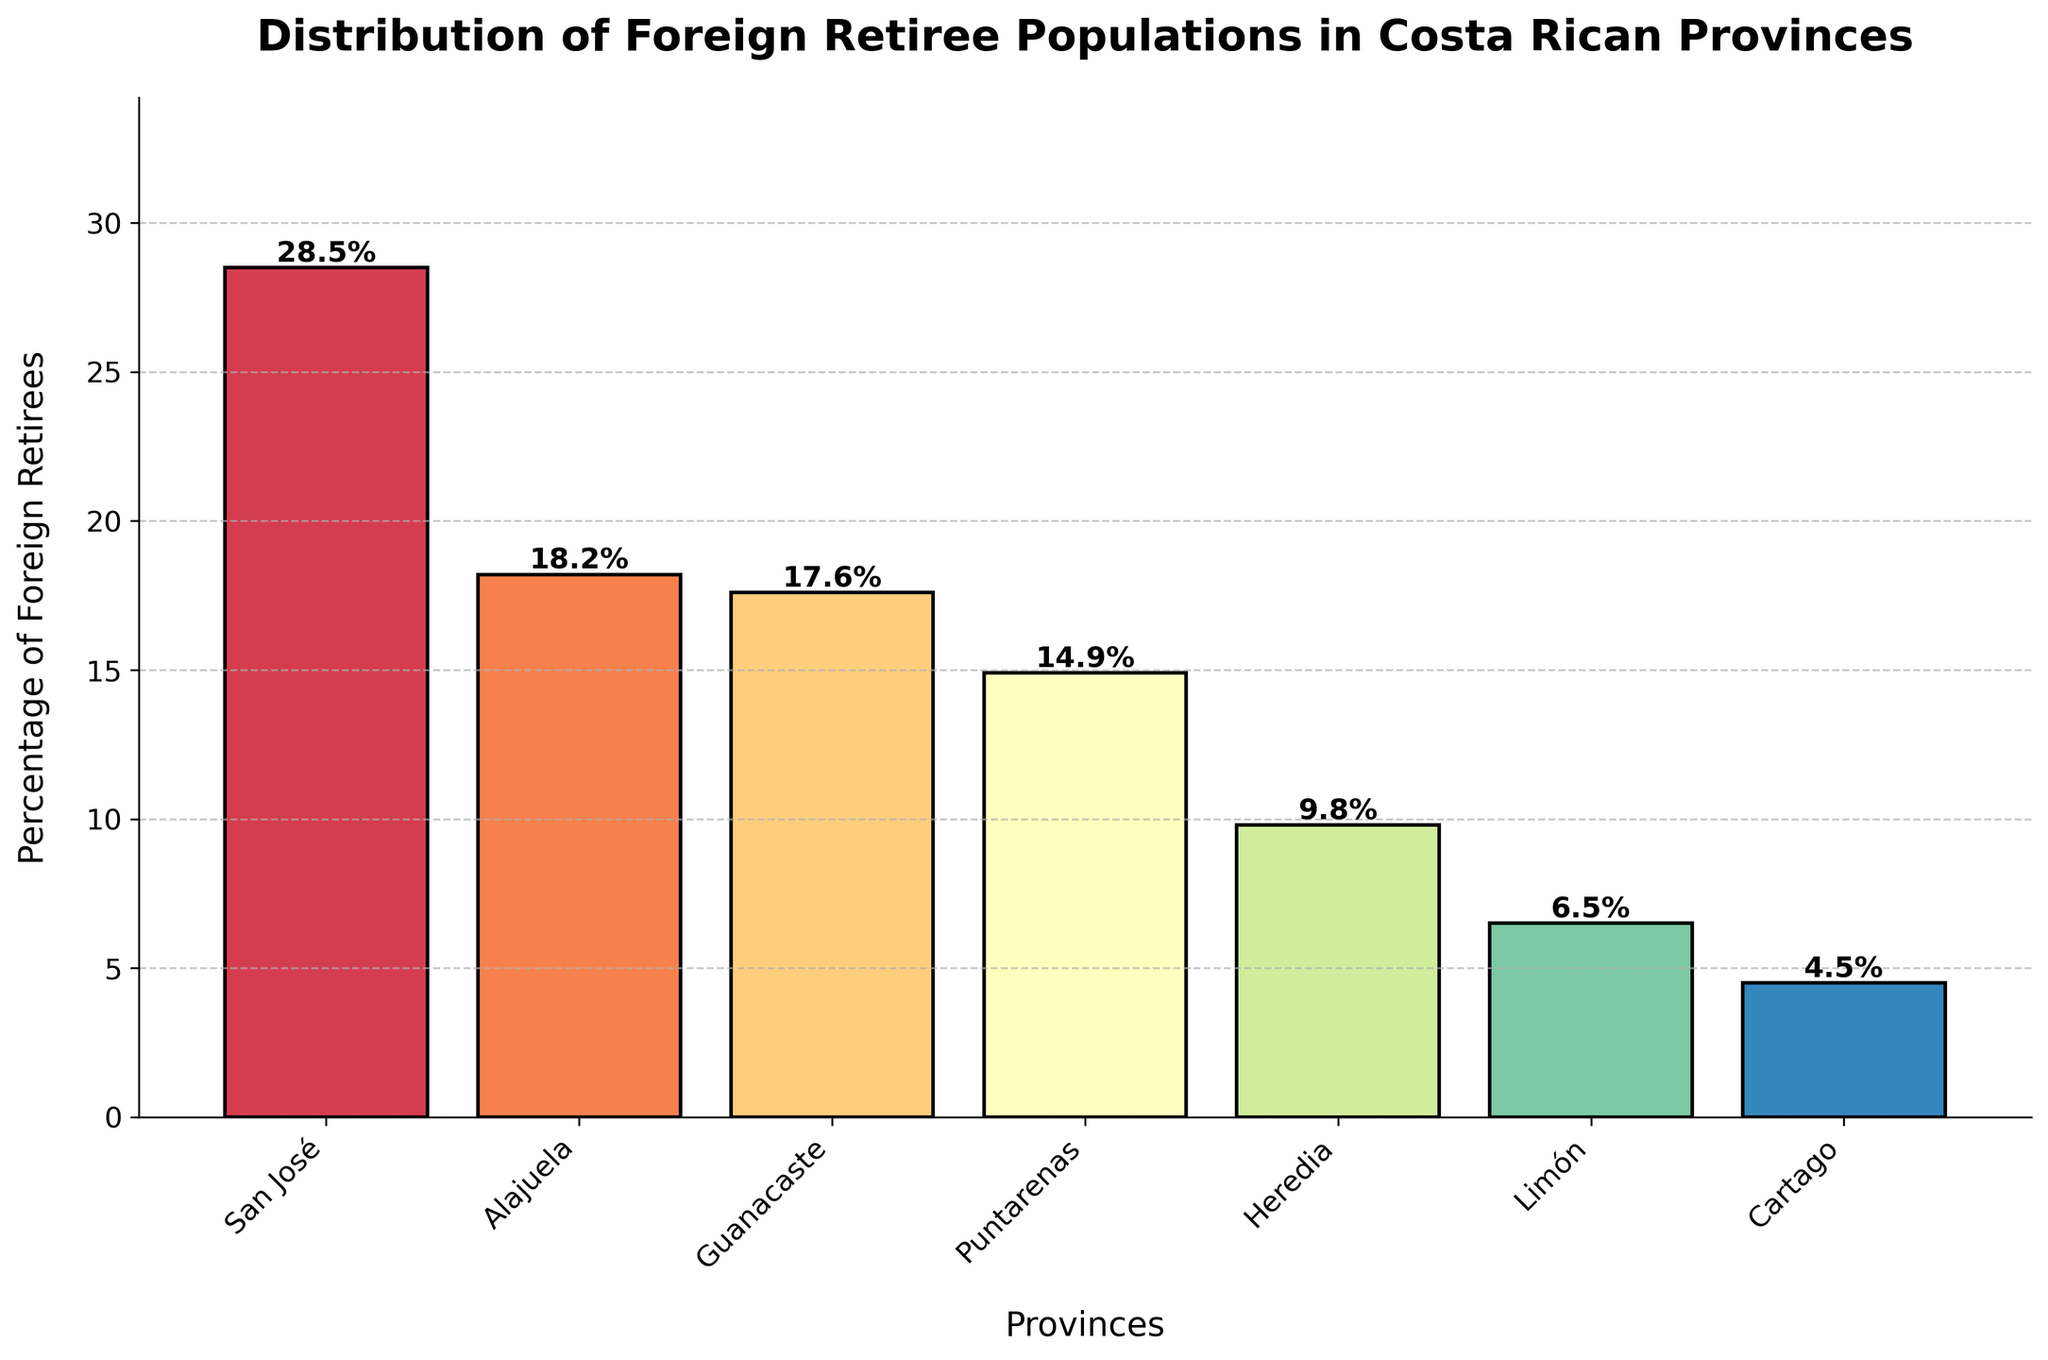Which province has the highest percentage of foreign retirees? Look at the highest bar in the chart and identify the province it represents. The highest bar corresponds to San José.
Answer: San José Which two provinces have the closest percentages of foreign retirees? Compare the heights of the bars to find the two that are closest in value. Guanacaste and Alajuela have percentages of 17.6% and 18.2%, respectively, which are very close.
Answer: Guanacaste and Alajuela What is the percentage difference between the province with the highest and the province with the lowest foreign retiree populations? Identify the highest and lowest percentages: San José (28.5%) and Cartago (4.5%). The difference is 28.5% - 4.5%.
Answer: 24% Which provinces have a percentage of foreign retirees below 10%? Look for bars with heights less than 10%. Heredia (9.8%), Limón (6.5%), and Cartago (4.5%) are below 10%.
Answer: Heredia, Limón, and Cartago What's the average percentage of foreign retirees for Puntarenas, Heredia, and Limón? Sum the percentages for the three provinces and divide by 3. (14.9 + 9.8 + 6.5) / 3 = 10.4%.
Answer: 10.4% Which province ranks third in terms of foreign retirees percentage, and what is the percentage? Rank the provinces based on the heights of the bars. The third highest bar is Guanacaste with 17.6%.
Answer: Guanacaste, 17.6% If the percentages for San José and Puntarenas are combined, what portion of the total does it represent? Add the percentages for San José and Puntarenas: 28.5% + 14.9% = 43.4%.
Answer: 43.4% Which two adjacent provinces in the bar chart have the biggest difference in their foreign retiree populations? Look for the pair of adjacent bars with the largest difference. San José (28.5%) and Alajuela (18.2%) have a difference of 28.5% - 18.2% = 10.3%.
Answer: San José and Alajuela Which province has a roughly mid-range percentage of foreign retirees among the given provinces, and what is the percentage? Ranking the percentages: mid-ranged will be Heredia with 9.8%.
Answer: Heredia, 9.8% How many provinces have a percentage higher than the average percentage of all provinces? Calculate the average percentage of all provinces first: (28.5 + 18.2 + 17.6 + 14.9 + 9.8 + 6.5 + 4.5) / 7 = 14.3%. Provinces higher than 14.3% are San José, Alajuela, Guanacaste, and Puntarenas.
Answer: 4 